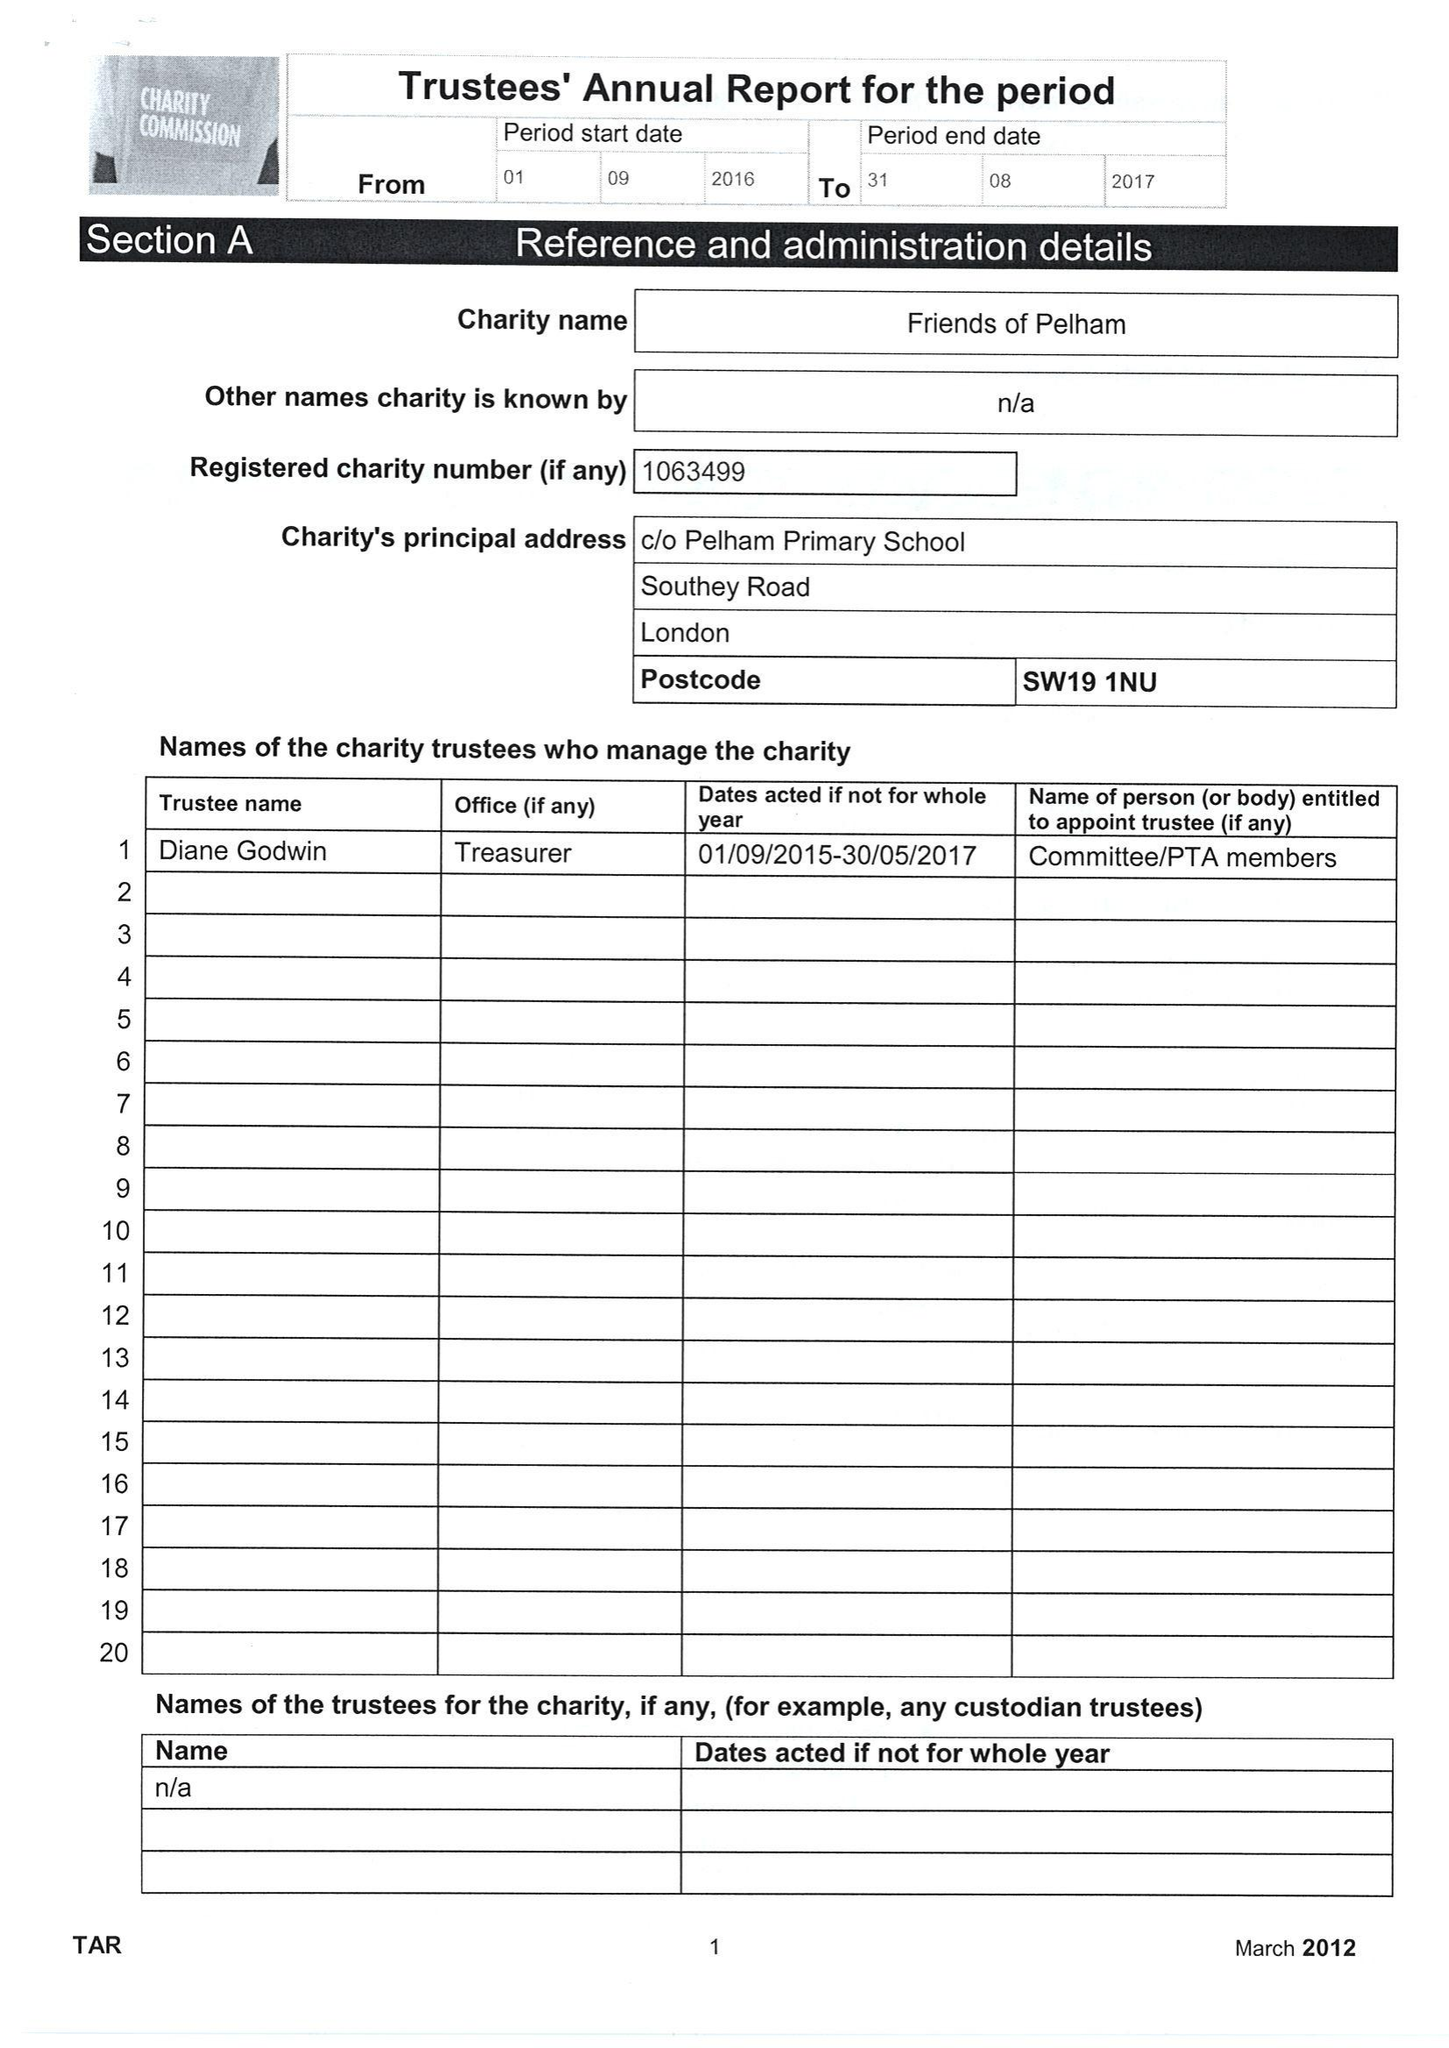What is the value for the address__street_line?
Answer the question using a single word or phrase. SOUTHEY ROAD 